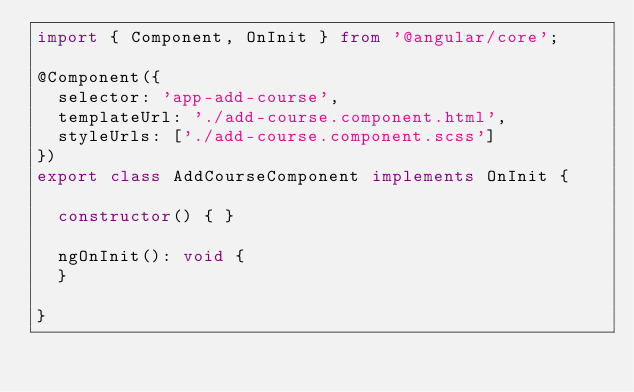Convert code to text. <code><loc_0><loc_0><loc_500><loc_500><_TypeScript_>import { Component, OnInit } from '@angular/core';

@Component({
  selector: 'app-add-course',
  templateUrl: './add-course.component.html',
  styleUrls: ['./add-course.component.scss']
})
export class AddCourseComponent implements OnInit {

  constructor() { }

  ngOnInit(): void {
  }

}
</code> 